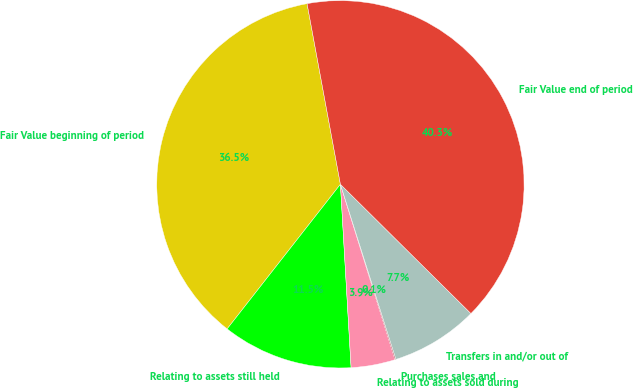Convert chart to OTSL. <chart><loc_0><loc_0><loc_500><loc_500><pie_chart><fcel>Fair Value beginning of period<fcel>Relating to assets still held<fcel>Relating to assets sold during<fcel>Purchases sales and<fcel>Transfers in and/or out of<fcel>Fair Value end of period<nl><fcel>36.52%<fcel>11.5%<fcel>3.88%<fcel>0.08%<fcel>7.69%<fcel>40.33%<nl></chart> 